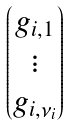Convert formula to latex. <formula><loc_0><loc_0><loc_500><loc_500>\begin{pmatrix} g _ { i , 1 } \\ \vdots \\ g _ { i , \nu _ { i } } \end{pmatrix}</formula> 